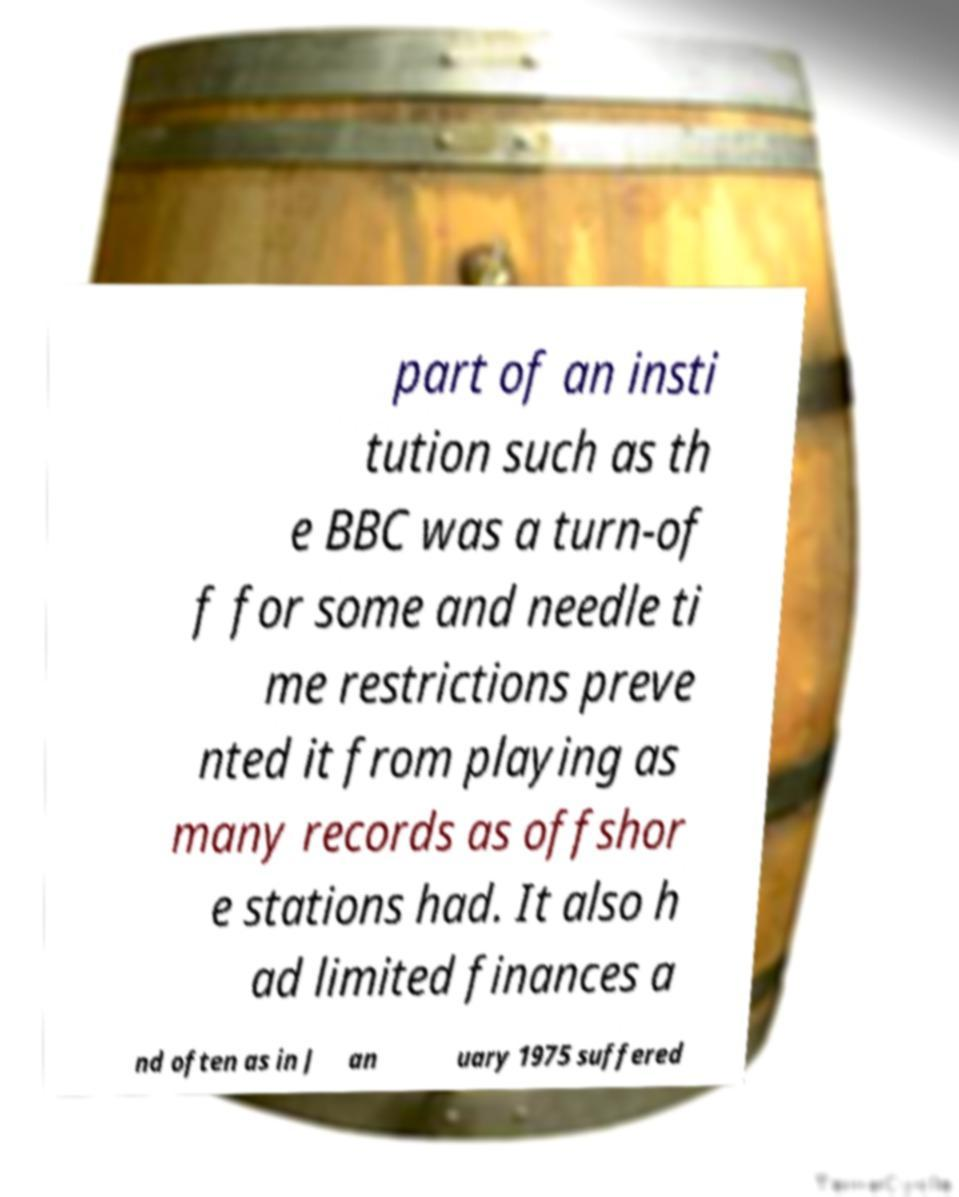I need the written content from this picture converted into text. Can you do that? part of an insti tution such as th e BBC was a turn-of f for some and needle ti me restrictions preve nted it from playing as many records as offshor e stations had. It also h ad limited finances a nd often as in J an uary 1975 suffered 